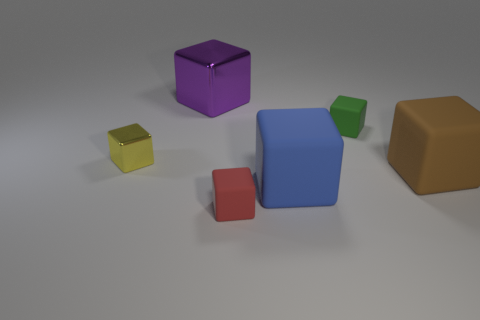Are there any large purple cubes in front of the green object?
Keep it short and to the point. No. Is the large purple thing the same shape as the tiny shiny thing?
Provide a succinct answer. Yes. There is a rubber thing behind the large rubber thing on the right side of the small matte object that is behind the brown rubber thing; what is its size?
Make the answer very short. Small. What is the big purple object made of?
Offer a very short reply. Metal. There is a big brown object; is it the same shape as the metallic thing in front of the tiny green matte cube?
Your answer should be compact. Yes. There is a big object that is behind the big object that is to the right of the rubber block that is behind the brown thing; what is it made of?
Keep it short and to the point. Metal. What number of large cyan metal cylinders are there?
Keep it short and to the point. 0. How many gray objects are blocks or big metal things?
Offer a very short reply. 0. What number of other objects are the same shape as the blue rubber object?
Your answer should be compact. 5. What number of big objects are either yellow blocks or red objects?
Ensure brevity in your answer.  0. 